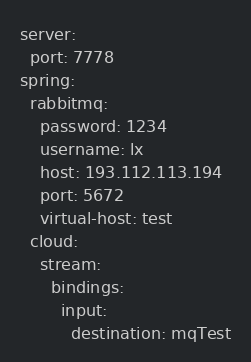Convert code to text. <code><loc_0><loc_0><loc_500><loc_500><_YAML_>server:
  port: 7778
spring:
  rabbitmq:
    password: 1234
    username: lx
    host: 193.112.113.194
    port: 5672
    virtual-host: test
  cloud:
    stream:
      bindings:
        input:
          destination: mqTest
</code> 